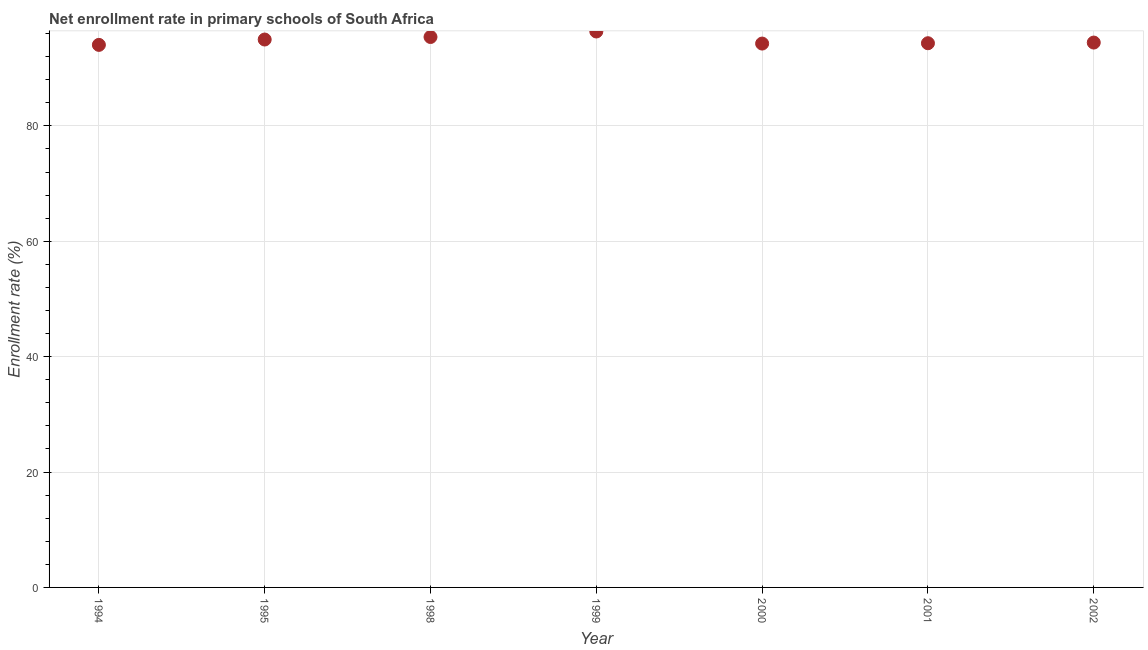What is the net enrollment rate in primary schools in 1999?
Your response must be concise. 96.35. Across all years, what is the maximum net enrollment rate in primary schools?
Your answer should be compact. 96.35. Across all years, what is the minimum net enrollment rate in primary schools?
Your answer should be compact. 94.03. In which year was the net enrollment rate in primary schools maximum?
Your answer should be compact. 1999. In which year was the net enrollment rate in primary schools minimum?
Your response must be concise. 1994. What is the sum of the net enrollment rate in primary schools?
Your answer should be very brief. 663.76. What is the difference between the net enrollment rate in primary schools in 1994 and 1995?
Make the answer very short. -0.93. What is the average net enrollment rate in primary schools per year?
Give a very brief answer. 94.82. What is the median net enrollment rate in primary schools?
Ensure brevity in your answer.  94.43. What is the ratio of the net enrollment rate in primary schools in 1995 to that in 2002?
Ensure brevity in your answer.  1.01. Is the difference between the net enrollment rate in primary schools in 2000 and 2002 greater than the difference between any two years?
Keep it short and to the point. No. What is the difference between the highest and the second highest net enrollment rate in primary schools?
Your answer should be compact. 0.95. What is the difference between the highest and the lowest net enrollment rate in primary schools?
Provide a short and direct response. 2.32. In how many years, is the net enrollment rate in primary schools greater than the average net enrollment rate in primary schools taken over all years?
Your answer should be compact. 3. Does the net enrollment rate in primary schools monotonically increase over the years?
Your response must be concise. No. How many years are there in the graph?
Provide a succinct answer. 7. What is the difference between two consecutive major ticks on the Y-axis?
Provide a succinct answer. 20. Are the values on the major ticks of Y-axis written in scientific E-notation?
Your answer should be very brief. No. What is the title of the graph?
Keep it short and to the point. Net enrollment rate in primary schools of South Africa. What is the label or title of the Y-axis?
Offer a terse response. Enrollment rate (%). What is the Enrollment rate (%) in 1994?
Give a very brief answer. 94.03. What is the Enrollment rate (%) in 1995?
Ensure brevity in your answer.  94.96. What is the Enrollment rate (%) in 1998?
Provide a succinct answer. 95.4. What is the Enrollment rate (%) in 1999?
Ensure brevity in your answer.  96.35. What is the Enrollment rate (%) in 2000?
Ensure brevity in your answer.  94.26. What is the Enrollment rate (%) in 2001?
Your answer should be compact. 94.32. What is the Enrollment rate (%) in 2002?
Your answer should be very brief. 94.43. What is the difference between the Enrollment rate (%) in 1994 and 1995?
Provide a short and direct response. -0.93. What is the difference between the Enrollment rate (%) in 1994 and 1998?
Offer a terse response. -1.37. What is the difference between the Enrollment rate (%) in 1994 and 1999?
Provide a short and direct response. -2.32. What is the difference between the Enrollment rate (%) in 1994 and 2000?
Your response must be concise. -0.23. What is the difference between the Enrollment rate (%) in 1994 and 2001?
Give a very brief answer. -0.29. What is the difference between the Enrollment rate (%) in 1994 and 2002?
Provide a succinct answer. -0.4. What is the difference between the Enrollment rate (%) in 1995 and 1998?
Your response must be concise. -0.44. What is the difference between the Enrollment rate (%) in 1995 and 1999?
Ensure brevity in your answer.  -1.39. What is the difference between the Enrollment rate (%) in 1995 and 2000?
Provide a short and direct response. 0.7. What is the difference between the Enrollment rate (%) in 1995 and 2001?
Make the answer very short. 0.64. What is the difference between the Enrollment rate (%) in 1995 and 2002?
Ensure brevity in your answer.  0.53. What is the difference between the Enrollment rate (%) in 1998 and 1999?
Give a very brief answer. -0.95. What is the difference between the Enrollment rate (%) in 1998 and 2000?
Make the answer very short. 1.14. What is the difference between the Enrollment rate (%) in 1998 and 2001?
Provide a short and direct response. 1.08. What is the difference between the Enrollment rate (%) in 1998 and 2002?
Offer a terse response. 0.97. What is the difference between the Enrollment rate (%) in 1999 and 2000?
Offer a terse response. 2.09. What is the difference between the Enrollment rate (%) in 1999 and 2001?
Offer a terse response. 2.03. What is the difference between the Enrollment rate (%) in 1999 and 2002?
Your response must be concise. 1.92. What is the difference between the Enrollment rate (%) in 2000 and 2001?
Your response must be concise. -0.06. What is the difference between the Enrollment rate (%) in 2000 and 2002?
Make the answer very short. -0.17. What is the difference between the Enrollment rate (%) in 2001 and 2002?
Provide a succinct answer. -0.12. What is the ratio of the Enrollment rate (%) in 1994 to that in 1995?
Make the answer very short. 0.99. What is the ratio of the Enrollment rate (%) in 1994 to that in 1998?
Ensure brevity in your answer.  0.99. What is the ratio of the Enrollment rate (%) in 1994 to that in 2001?
Give a very brief answer. 1. What is the ratio of the Enrollment rate (%) in 1994 to that in 2002?
Offer a very short reply. 1. What is the ratio of the Enrollment rate (%) in 1995 to that in 1998?
Keep it short and to the point. 0.99. What is the ratio of the Enrollment rate (%) in 1995 to that in 1999?
Offer a terse response. 0.99. What is the ratio of the Enrollment rate (%) in 1995 to that in 2000?
Make the answer very short. 1.01. What is the ratio of the Enrollment rate (%) in 1995 to that in 2001?
Ensure brevity in your answer.  1.01. What is the ratio of the Enrollment rate (%) in 1995 to that in 2002?
Give a very brief answer. 1.01. What is the ratio of the Enrollment rate (%) in 1998 to that in 2001?
Keep it short and to the point. 1.01. What is the ratio of the Enrollment rate (%) in 1999 to that in 2001?
Your response must be concise. 1.02. What is the ratio of the Enrollment rate (%) in 1999 to that in 2002?
Your answer should be very brief. 1.02. What is the ratio of the Enrollment rate (%) in 2001 to that in 2002?
Make the answer very short. 1. 